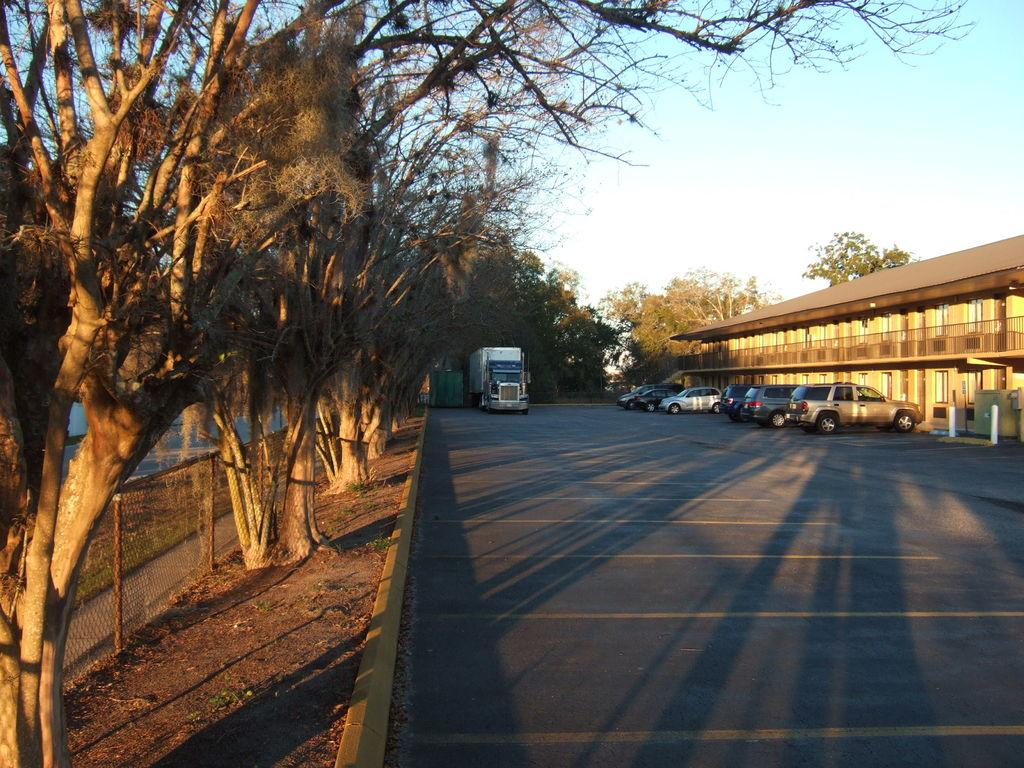What type of natural elements can be seen in the image? There are trees in the image. What type of man-made structures are visible in the image? There are buildings in the image. What type of transportation is present in the image? There are vehicles in the image. What type of vertical structures can be seen in the image? There are poles in the image. What type of safety or barrier structures can be seen in the image? There are railings in the image. What type of fencing is present in the image? There is net fencing in the image. What is the color of the sky in the image? The sky is blue and white in color. What type of men can be seen in the image? There are no men present in the image. What type of suggestion is being made in the image? There is no suggestion being made in the image. 